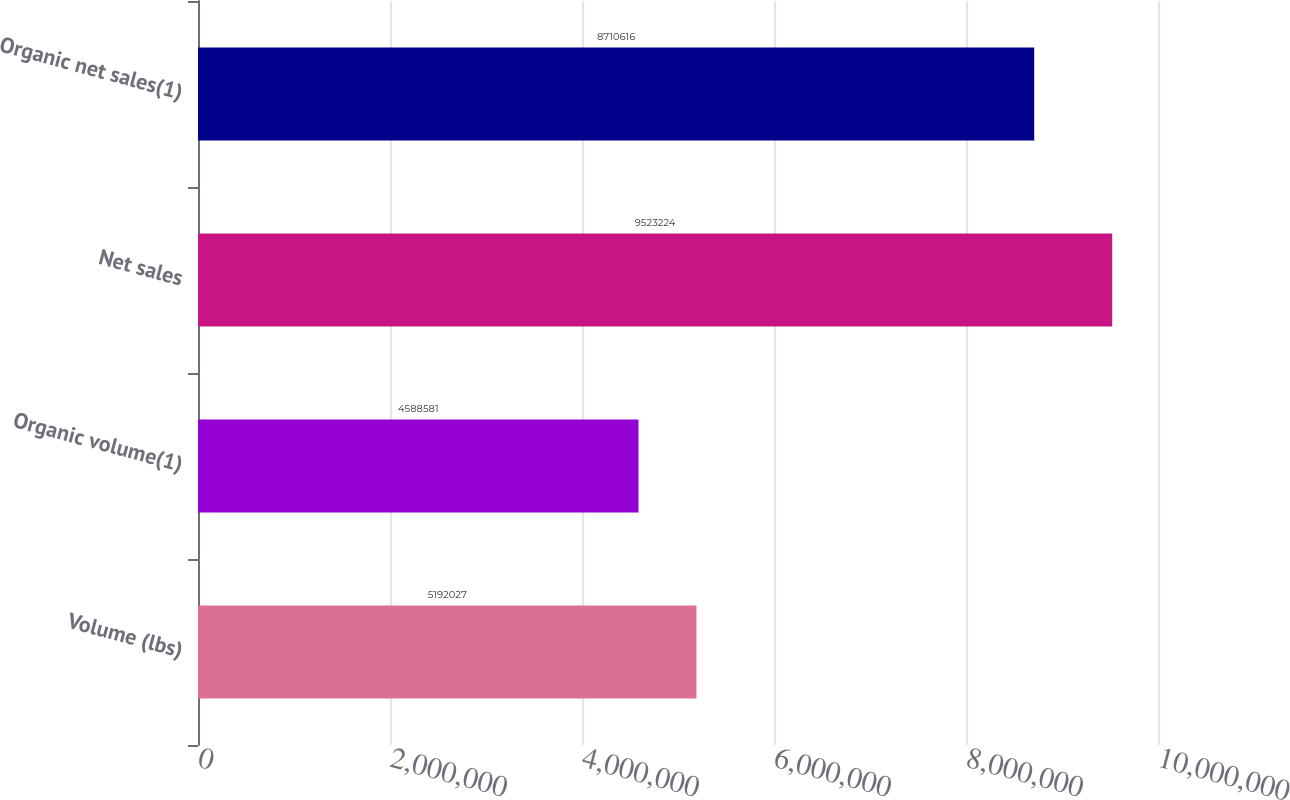Convert chart to OTSL. <chart><loc_0><loc_0><loc_500><loc_500><bar_chart><fcel>Volume (lbs)<fcel>Organic volume(1)<fcel>Net sales<fcel>Organic net sales(1)<nl><fcel>5.19203e+06<fcel>4.58858e+06<fcel>9.52322e+06<fcel>8.71062e+06<nl></chart> 